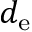Convert formula to latex. <formula><loc_0><loc_0><loc_500><loc_500>d _ { e }</formula> 